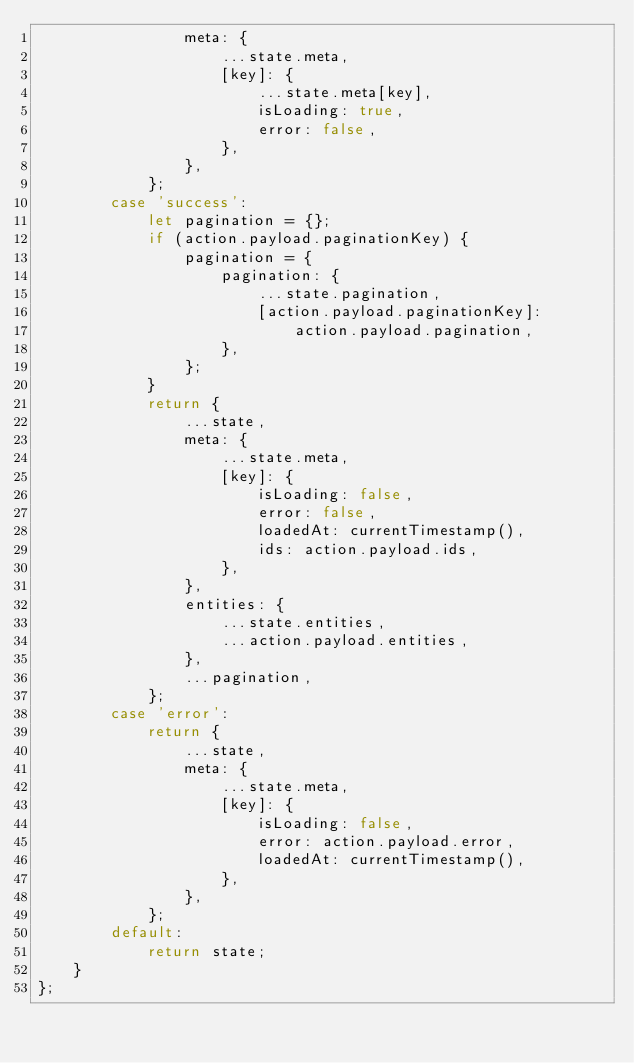<code> <loc_0><loc_0><loc_500><loc_500><_JavaScript_>                meta: {
                    ...state.meta,
                    [key]: {
                        ...state.meta[key],
                        isLoading: true,
                        error: false,
                    },
                },
            };
        case 'success':
            let pagination = {};
            if (action.payload.paginationKey) {
                pagination = {
                    pagination: {
                        ...state.pagination,
                        [action.payload.paginationKey]:
                            action.payload.pagination,
                    },
                };
            }
            return {
                ...state,
                meta: {
                    ...state.meta,
                    [key]: {
                        isLoading: false,
                        error: false,
                        loadedAt: currentTimestamp(),
                        ids: action.payload.ids,
                    },
                },
                entities: {
                    ...state.entities,
                    ...action.payload.entities,
                },
                ...pagination,
            };
        case 'error':
            return {
                ...state,
                meta: {
                    ...state.meta,
                    [key]: {
                        isLoading: false,
                        error: action.payload.error,
                        loadedAt: currentTimestamp(),
                    },
                },
            };
        default:
            return state;
    }
};
</code> 